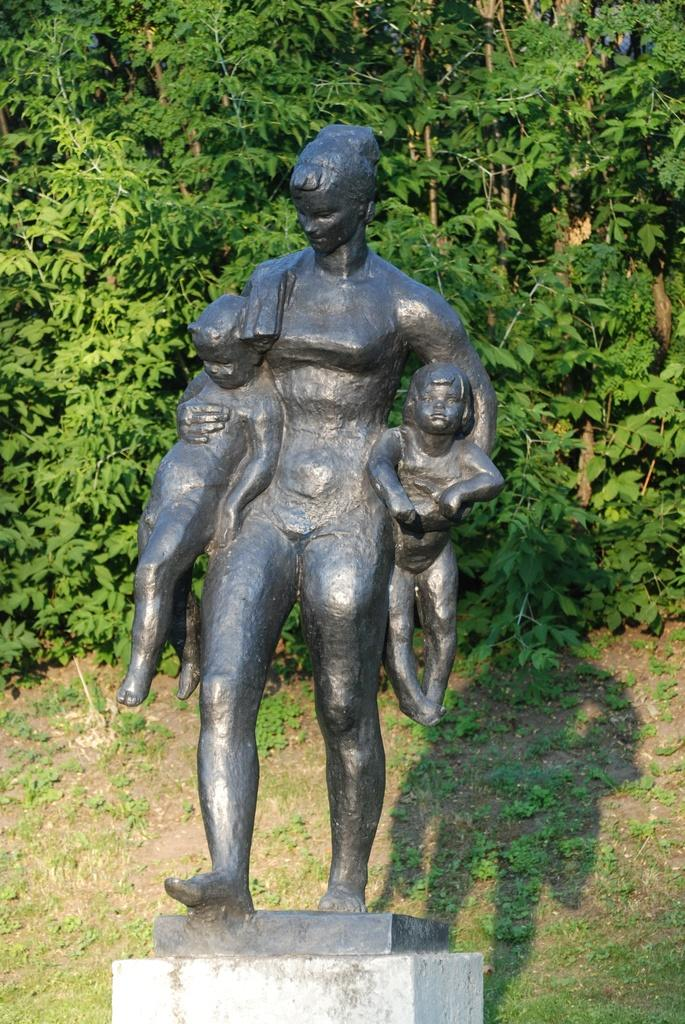What is the subject of the sculpture in the image? The sculpture is of a woman holding two kids. What type of vegetation is present in the image? There are trees with branches and leaves in the image. Can you describe any additional features of the sculpture? The shadow of the sculpture is visible in the image. How many pizzas are hanging from the branches of the trees in the image? There are no pizzas present in the image; it features a sculpture and trees with branches and leaves. 